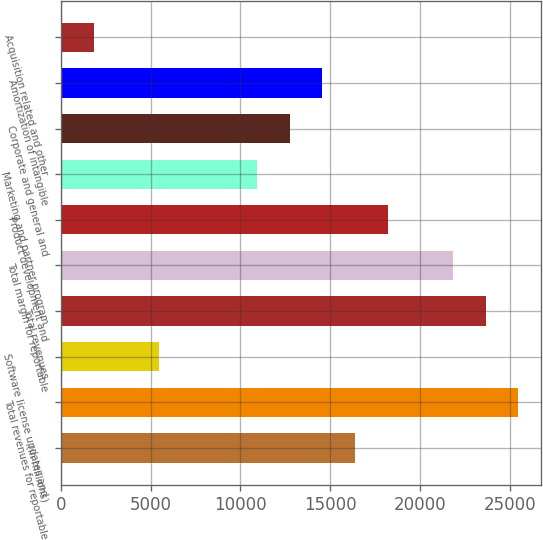<chart> <loc_0><loc_0><loc_500><loc_500><bar_chart><fcel>(in millions)<fcel>Total revenues for reportable<fcel>Software license updates and<fcel>Total revenues<fcel>Total margin for reportable<fcel>Product development and<fcel>Marketing and partner program<fcel>Corporate and general and<fcel>Amortization of intangible<fcel>Acquisition related and other<nl><fcel>16389.1<fcel>25483.6<fcel>5475.7<fcel>23664.7<fcel>21845.8<fcel>18208<fcel>10932.4<fcel>12751.3<fcel>14570.2<fcel>1837.9<nl></chart> 